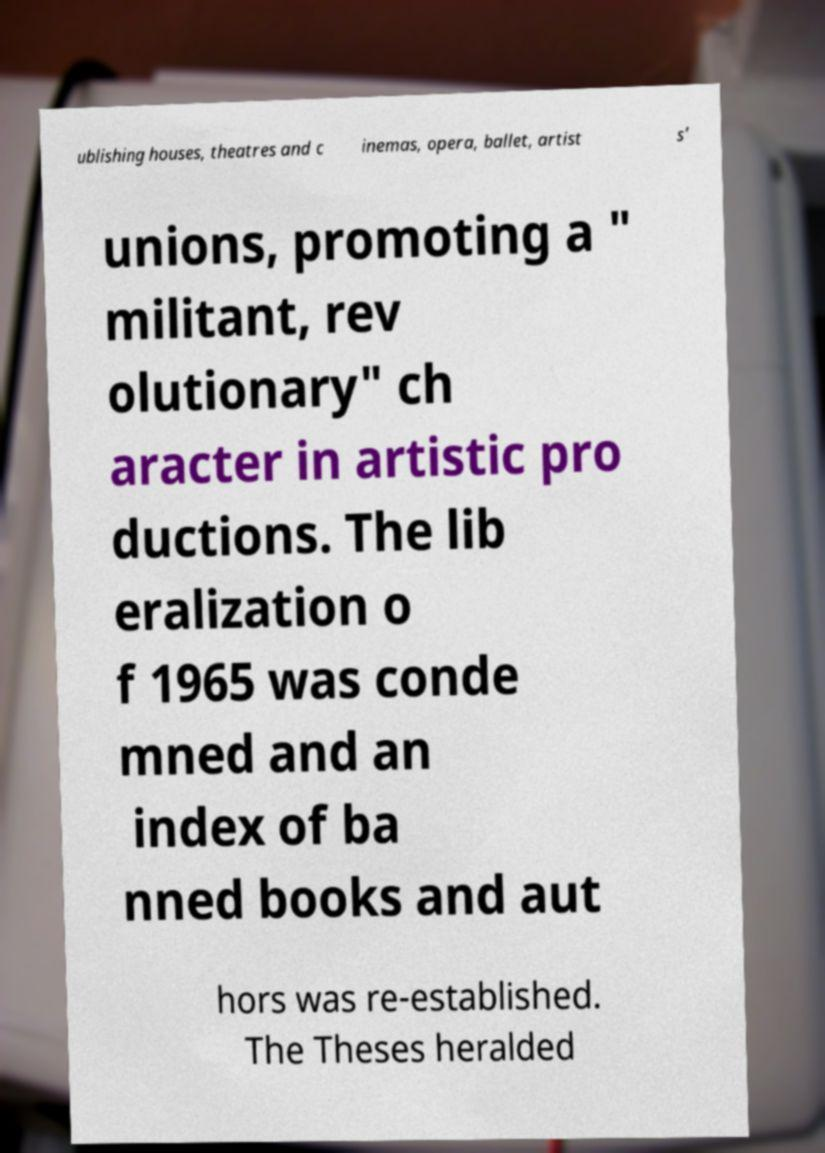Please identify and transcribe the text found in this image. ublishing houses, theatres and c inemas, opera, ballet, artist s' unions, promoting a " militant, rev olutionary" ch aracter in artistic pro ductions. The lib eralization o f 1965 was conde mned and an index of ba nned books and aut hors was re-established. The Theses heralded 